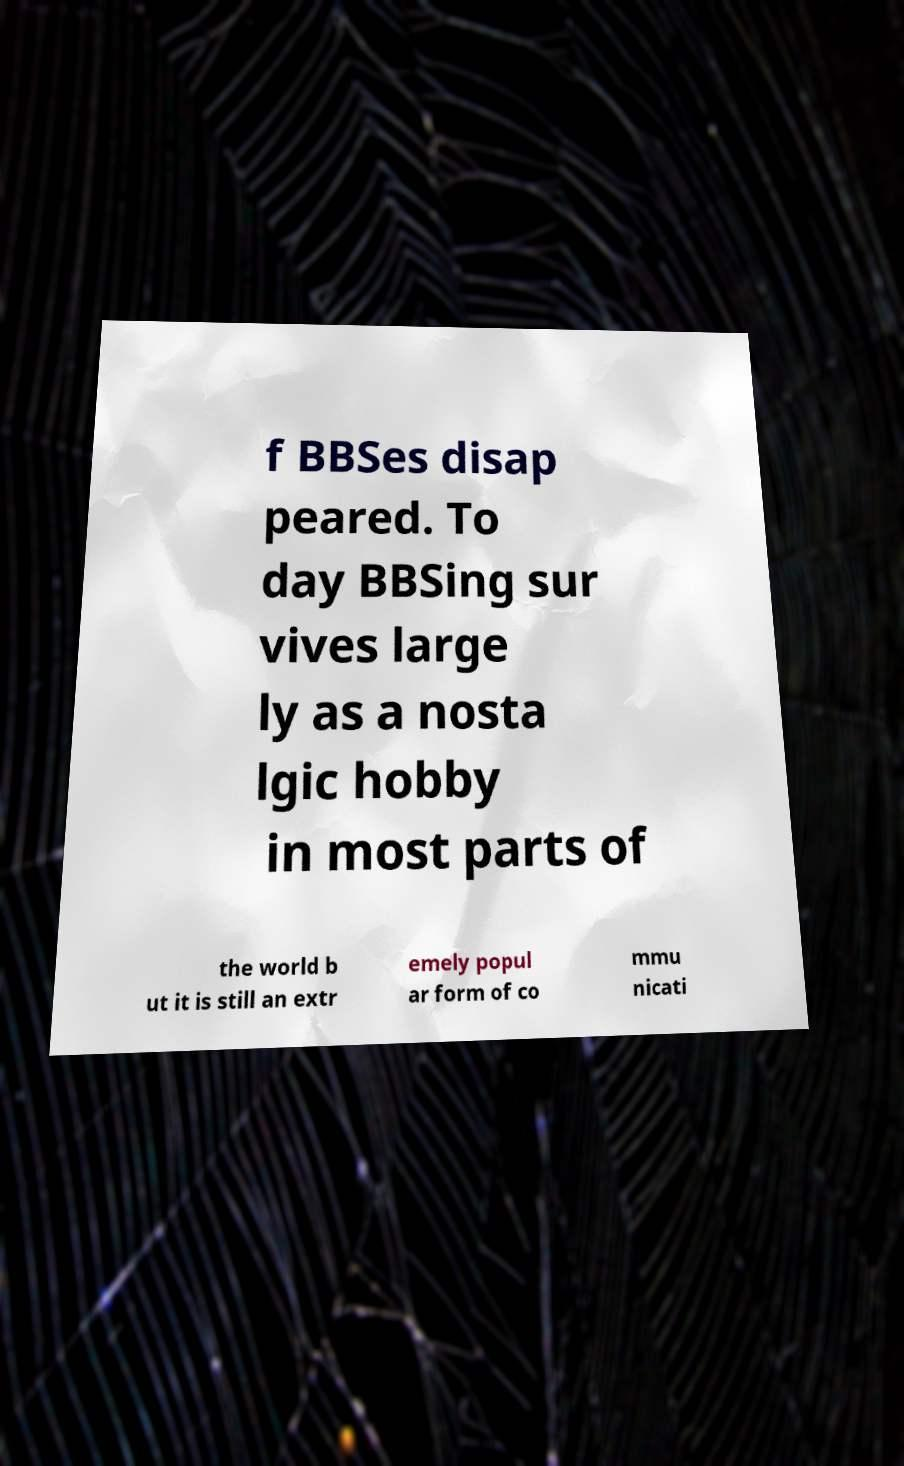Could you assist in decoding the text presented in this image and type it out clearly? f BBSes disap peared. To day BBSing sur vives large ly as a nosta lgic hobby in most parts of the world b ut it is still an extr emely popul ar form of co mmu nicati 